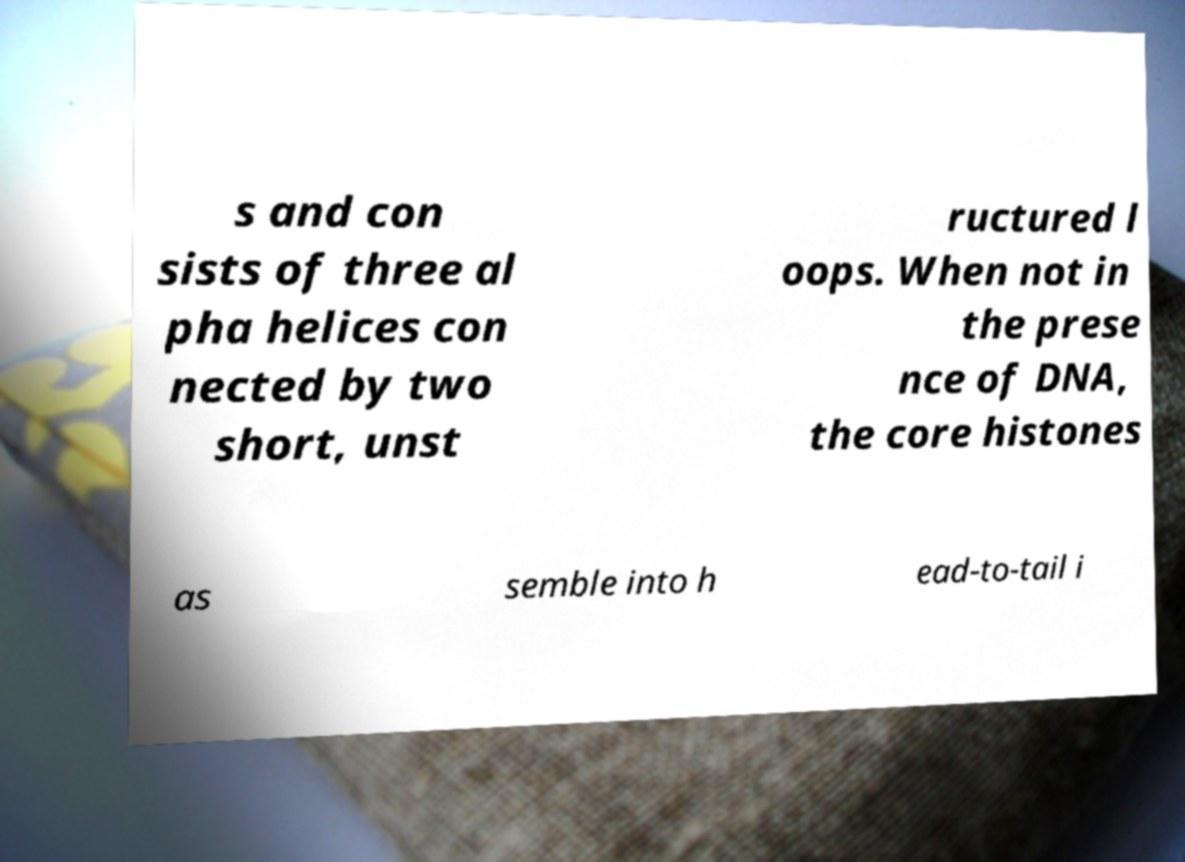What messages or text are displayed in this image? I need them in a readable, typed format. s and con sists of three al pha helices con nected by two short, unst ructured l oops. When not in the prese nce of DNA, the core histones as semble into h ead-to-tail i 